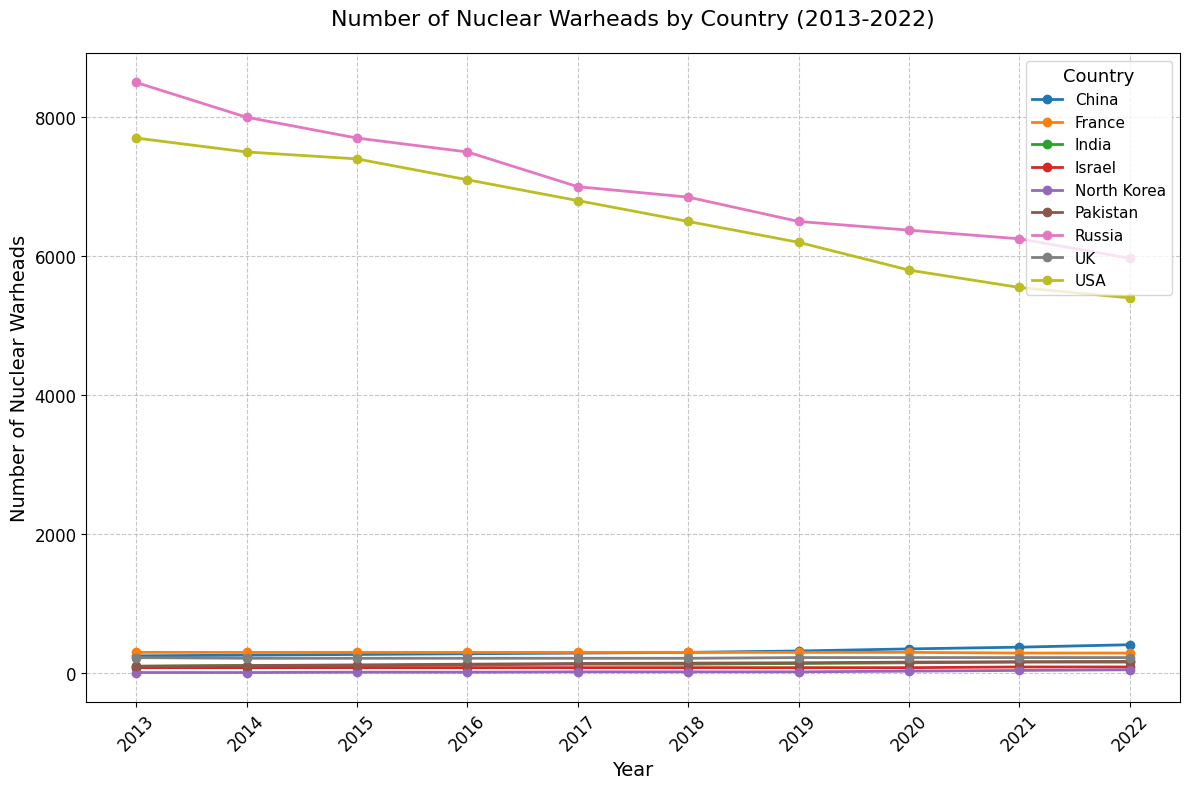Which country had the highest number of nuclear warheads in 2022? To determine the country with the highest number of nuclear warheads in 2022, look at the line that extends the farthest upward for the year 2022. The line for Russia is the highest, indicating Russia had the most warheads.
Answer: Russia How did the number of nuclear warheads in the USA change from 2013 to 2022? To find the change in the number of nuclear warheads in the USA from 2013 to 2022, subtract the 2022 value from the 2013 value. In 2013, the USA had 7700 warheads, and in 2022, it had 5400. Thus, 7700 - 5400 = 2300.
Answer: Decreased by 2300 Which country showed the most consistent number of nuclear warheads over the decade? The country with the most consistent number of warheads would have a relatively flat line. France, which maintains a nearly flat line, indicates a constant count of close to 300 warheads.
Answer: France Between China and India, which country had a larger increase in nuclear warheads from 2013 to 2022? To compare the increases, subtract the 2013 value from the 2022 value for both China and India. China increased from 250 to 410 (410 - 250 = 160), India from 100 to 160 (160 - 100 = 60). China had a larger increase.
Answer: China How does the number of nuclear warheads in the UK in 2013 compare to the number in 2022? To compare, look at the values for the UK in both years. The UK had 225 warheads in 2013 and also has 225 in 2022. Thus, the number stayed the same.
Answer: The same Which country had the greatest percentage increase in nuclear warheads over the decade? Calculate the percentage increase for each country by dividing the increase by the original number in 2013. For North Korea: (50-10)/10 = 4 or 400%, which is the highest percentage increase among the countries.
Answer: North Korea What is the average number of nuclear warheads for Israel over the decade? To find the average, sum the warheads from 2013 to 2022 and divide by the number of years (10). (80 * 8 + 90 * 2) / 10 = 82. Israel had 80 warheads for 8 years, and 90 for 2 years.
Answer: 82 Between Russia and Pakistan, which country had more nuclear warheads in 2016? Compare the respective values for 2016. Russia had 7500 warheads while Pakistan had 130.
Answer: Russia Which three countries had more than 200 nuclear warheads consistently every year from 2013 to 2022? Identify countries with values continuously above 200 for the entire period: USA, Russia, and UK maintain levels above 200 each year.
Answer: USA, Russia, UK What was the trend in nuclear warheads for North Korea from 2017 to 2022? Observe the data points for North Korea from 2017 to 2022; the trend shows a consistent increase from 20 to 50 within these years.
Answer: Increasing 